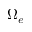<formula> <loc_0><loc_0><loc_500><loc_500>\Omega _ { e }</formula> 